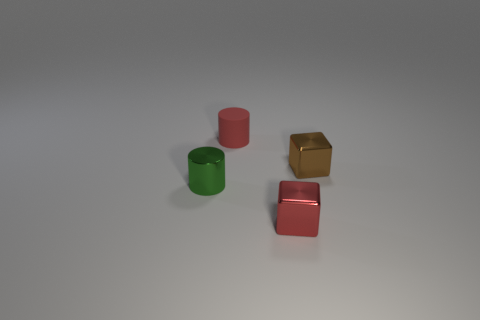Can you describe the lighting in the scene? Certainly! The image shows a soft overhead light creating gentle shadows to the right of the objects, which suggests a single diffuse light source positioned to the left out of frame. 